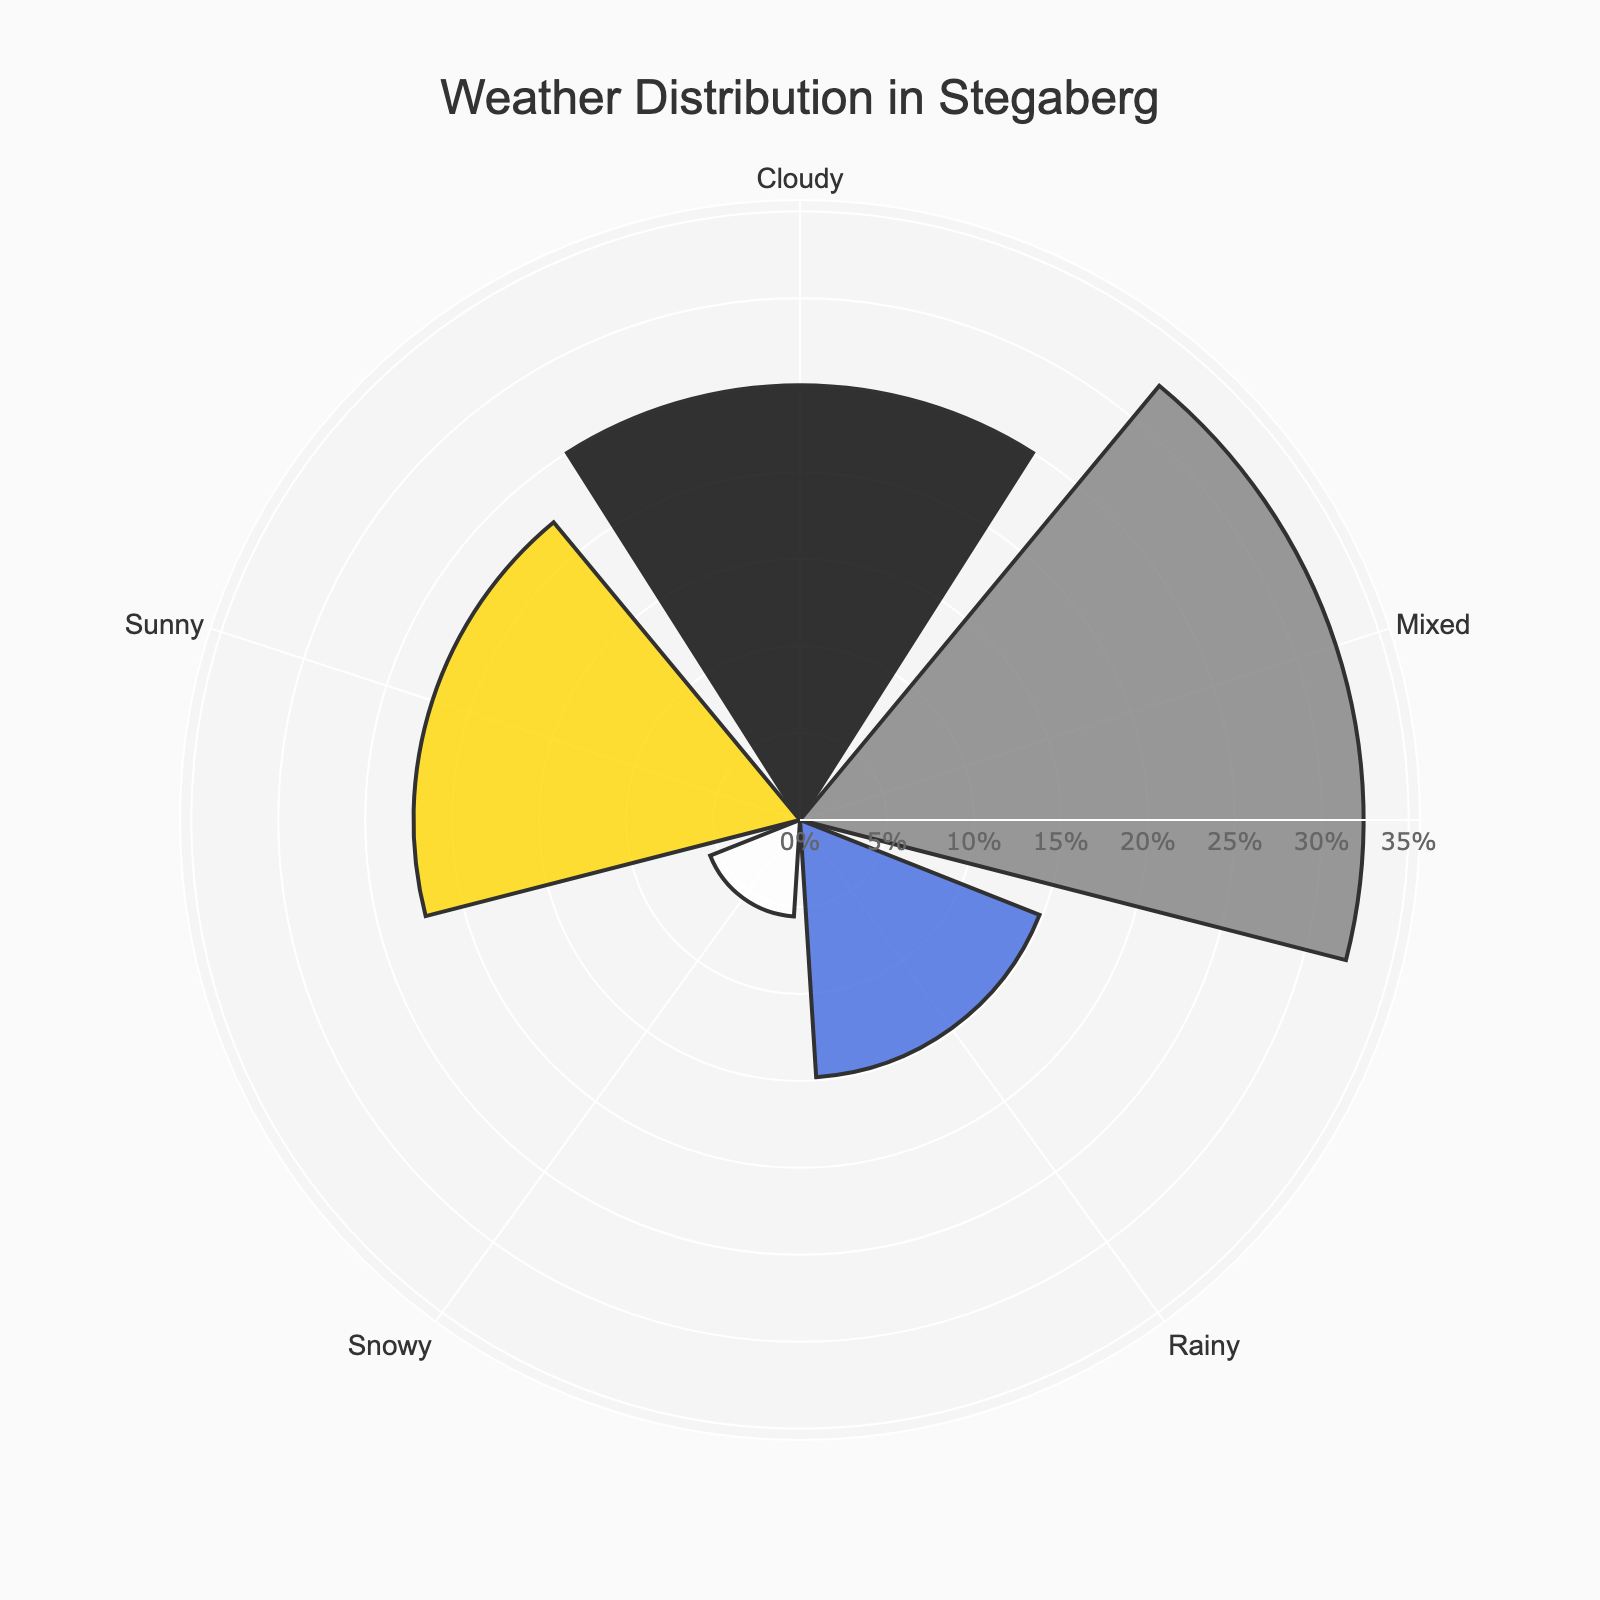What is the title of the rose chart? The title is situated at the top of the figure and provides context for the data being visualized. In this case, it describes the content of the chart.
Answer: Weather Distribution in Stegaberg How many weather categories are depicted in the rose chart? By observing the number of distinct sections in the chart, we can count the unique weather categories shown.
Answer: 4 Which weather condition has the highest percentage in the rose chart? Looking at the weather conditions around the rose chart, the section with the widest radius represents the highest percentage.
Answer: Cloudy What colors are used to represent different weather conditions in the chart? The rose chart uses different colors to distinguish between weather conditions. By referring to the visual color representation, we can list the colors used.
Answer: Sunny: gold, Rainy: blue, Snowy: white, Mixed: grey What percentage of days are categorized as 'Sunny'? By looking at the radial extent of the section labeled 'Sunny', we can identify its percentage from the associated label.
Answer: 21% How many days are represented by the 'Mixed' category, and what percentage do they form of the total? Calculating the total number of days first (120+80+30+135+100+75=540), the days listed for 'Mixed' categories (Cloudy/Sunny + Rainy/Cloudy = 100 + 75 = 175) can then be converted to a percentage: (175/540)*100%.
Answer: 175 days, 32.4% Which two weather conditions together make up over 50% of the total days? By adding the percentages of various combinations, we find which pair sums to more than half of the total. Cloudy (25%) and Mixed (32.4%) together surpass 50%.
Answer: Cloudy and Mixed Among the basic weather conditions (Sunny, Rainy, Snowy, Cloudy), which one has the least number of days? Identifying the section with the smallest radius among basic weather conditions gives the answer.
Answer: Snowy What's the difference in percentage between 'Sunny' and 'Rainy' weather conditions? Quantitatively find the difference between the percentages of Sunny (21%) and Rainy (15%).
Answer: 6% If you combine the days of 'Cloudy' with 'Mixed', what is the total percentage of those days? Adding the percentages for 'Cloudy' (25%) and 'Mixed' (32.4%) provides the combined percentage.
Answer: 57.4% 